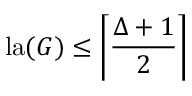Convert formula to latex. <formula><loc_0><loc_0><loc_500><loc_500>l a ( G ) \leq \left \lceil { \frac { \Delta + 1 } { 2 } } \right \rceil</formula> 